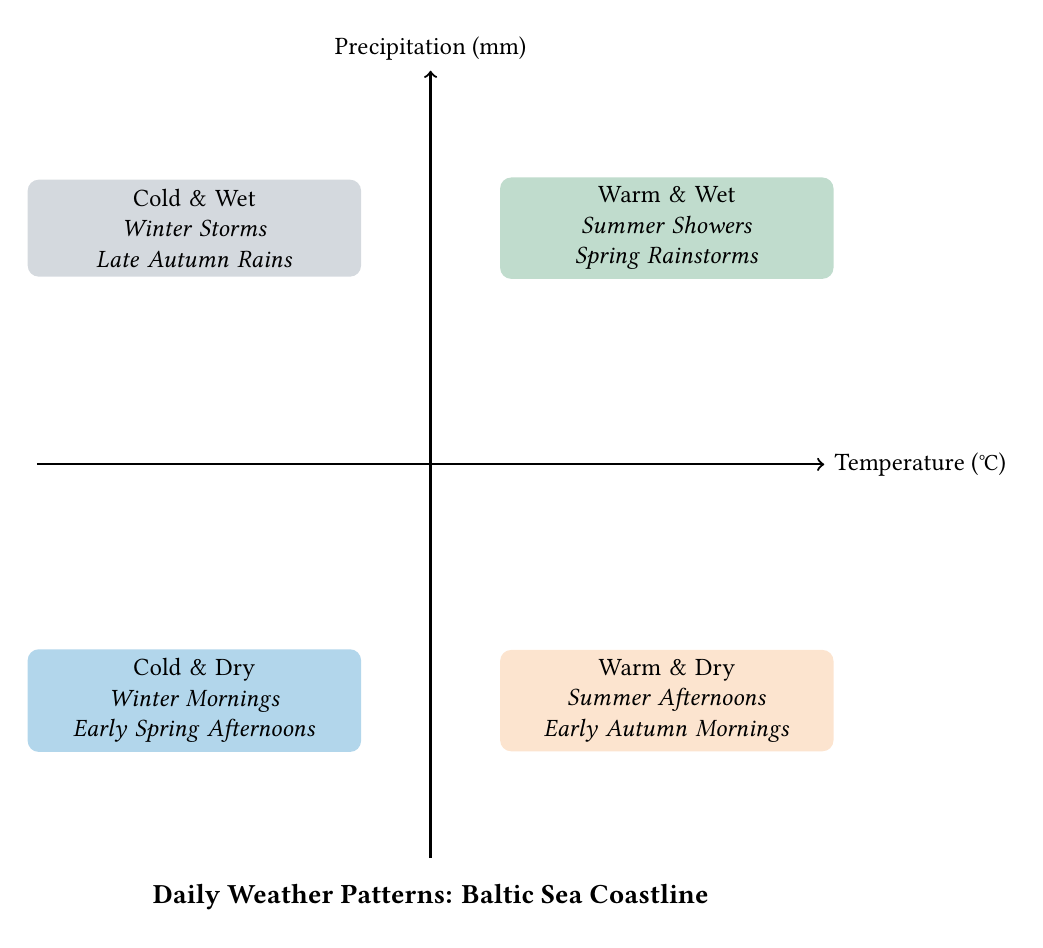What are the two categories in the upper left quadrant? The upper left quadrant represents areas where the temperature is low and precipitation is high. It is labeled "Cold & Wet" and includes examples like "Winter Storms" and "Late Autumn Rains."
Answer: Cold & Wet How many quadrants does the diagram have? The diagram has four quadrants, categorized by temperature and precipitation conditions.
Answer: 4 Which quadrant features "Summer Showers"? "Summer Showers" is listed in the upper right quadrant, which is categorized as "Warm & Wet." This indicates that it is characterized by higher temperatures and significant rainfall.
Answer: Warm & Wet What common weather pattern is associated with the "Warm & Dry" quadrant? The "Warm & Dry" quadrant is characterized by sunny beach days, associated with lower precipitation and higher temperature values, suitable for outdoor activities.
Answer: Sunny beach days What is the relationship between "Cold & Dry" and "Warm & Wet" quadrants? The "Cold & Dry" quadrant is in the lower left, while the "Warm & Wet" quadrant is in the upper right. This shows that as temperature increases (from left to right), precipitation levels can also rise (from bottom to top). Thus, they represent contrasting weather patterns in terms of temperature and moisture.
Answer: Contrasting Which quadrant would likely experience fog and snowfall? The "Cold & Wet" quadrant is known for conditions that bring fog and snowfall due to its combination of low temperatures and high precipitation levels, especially during winter.
Answer: Cold & Wet What kind of weather is likely during "Early Spring Afternoons"? "Early Spring Afternoons" is mentioned as an example in the "Cold & Dry" quadrant, indicating that this time is typically associated with lower precipitation and cooler temperatures.
Answer: Cold & Dry Which quadrant contains the phrase "frequent thunderstorms"? The phrase "frequent thunderstorms" is found in the description of the "Warm & Wet" quadrant. This suggests that high temperatures paired with significant precipitation can lead to stormy weather patterns.
Answer: Warm & Wet 